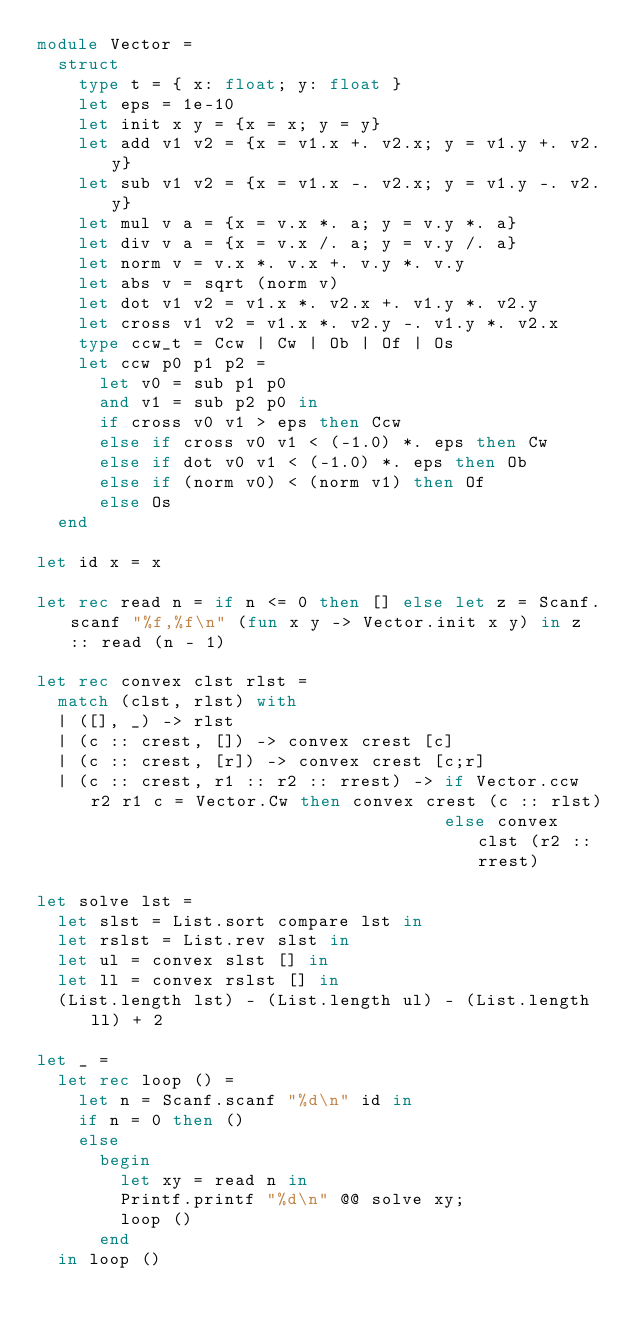Convert code to text. <code><loc_0><loc_0><loc_500><loc_500><_OCaml_>module Vector =
  struct
    type t = { x: float; y: float }
    let eps = 1e-10
    let init x y = {x = x; y = y}
    let add v1 v2 = {x = v1.x +. v2.x; y = v1.y +. v2.y}
    let sub v1 v2 = {x = v1.x -. v2.x; y = v1.y -. v2.y}
    let mul v a = {x = v.x *. a; y = v.y *. a}
    let div v a = {x = v.x /. a; y = v.y /. a}
    let norm v = v.x *. v.x +. v.y *. v.y
    let abs v = sqrt (norm v)
    let dot v1 v2 = v1.x *. v2.x +. v1.y *. v2.y
    let cross v1 v2 = v1.x *. v2.y -. v1.y *. v2.x
    type ccw_t = Ccw | Cw | Ob | Of | Os
    let ccw p0 p1 p2 =
      let v0 = sub p1 p0
      and v1 = sub p2 p0 in
      if cross v0 v1 > eps then Ccw
      else if cross v0 v1 < (-1.0) *. eps then Cw
      else if dot v0 v1 < (-1.0) *. eps then Ob
      else if (norm v0) < (norm v1) then Of
      else Os
  end

let id x = x

let rec read n = if n <= 0 then [] else let z = Scanf.scanf "%f,%f\n" (fun x y -> Vector.init x y) in z :: read (n - 1)

let rec convex clst rlst = 
  match (clst, rlst) with
  | ([], _) -> rlst
  | (c :: crest, []) -> convex crest [c]
  | (c :: crest, [r]) -> convex crest [c;r]
  | (c :: crest, r1 :: r2 :: rrest) -> if Vector.ccw r2 r1 c = Vector.Cw then convex crest (c :: rlst)
                                       else convex clst (r2 :: rrest)

let solve lst =
  let slst = List.sort compare lst in
  let rslst = List.rev slst in
  let ul = convex slst [] in
  let ll = convex rslst [] in
  (List.length lst) - (List.length ul) - (List.length ll) + 2

let _ = 
  let rec loop () = 
    let n = Scanf.scanf "%d\n" id in
    if n = 0 then ()
    else
      begin
        let xy = read n in
        Printf.printf "%d\n" @@ solve xy;
        loop ()
      end
  in loop ()</code> 